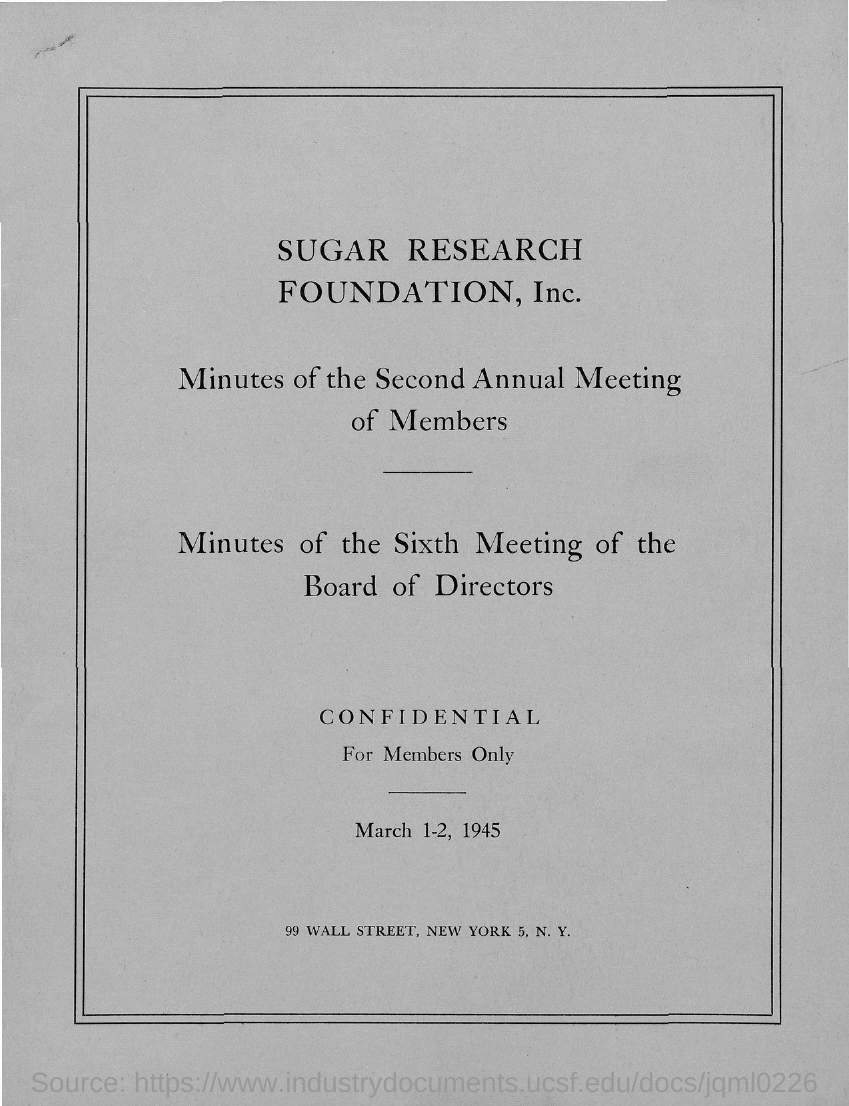Which company's minutes of meeting is mentioned here?
Offer a terse response. Sugar Research Foundation, Inc. 